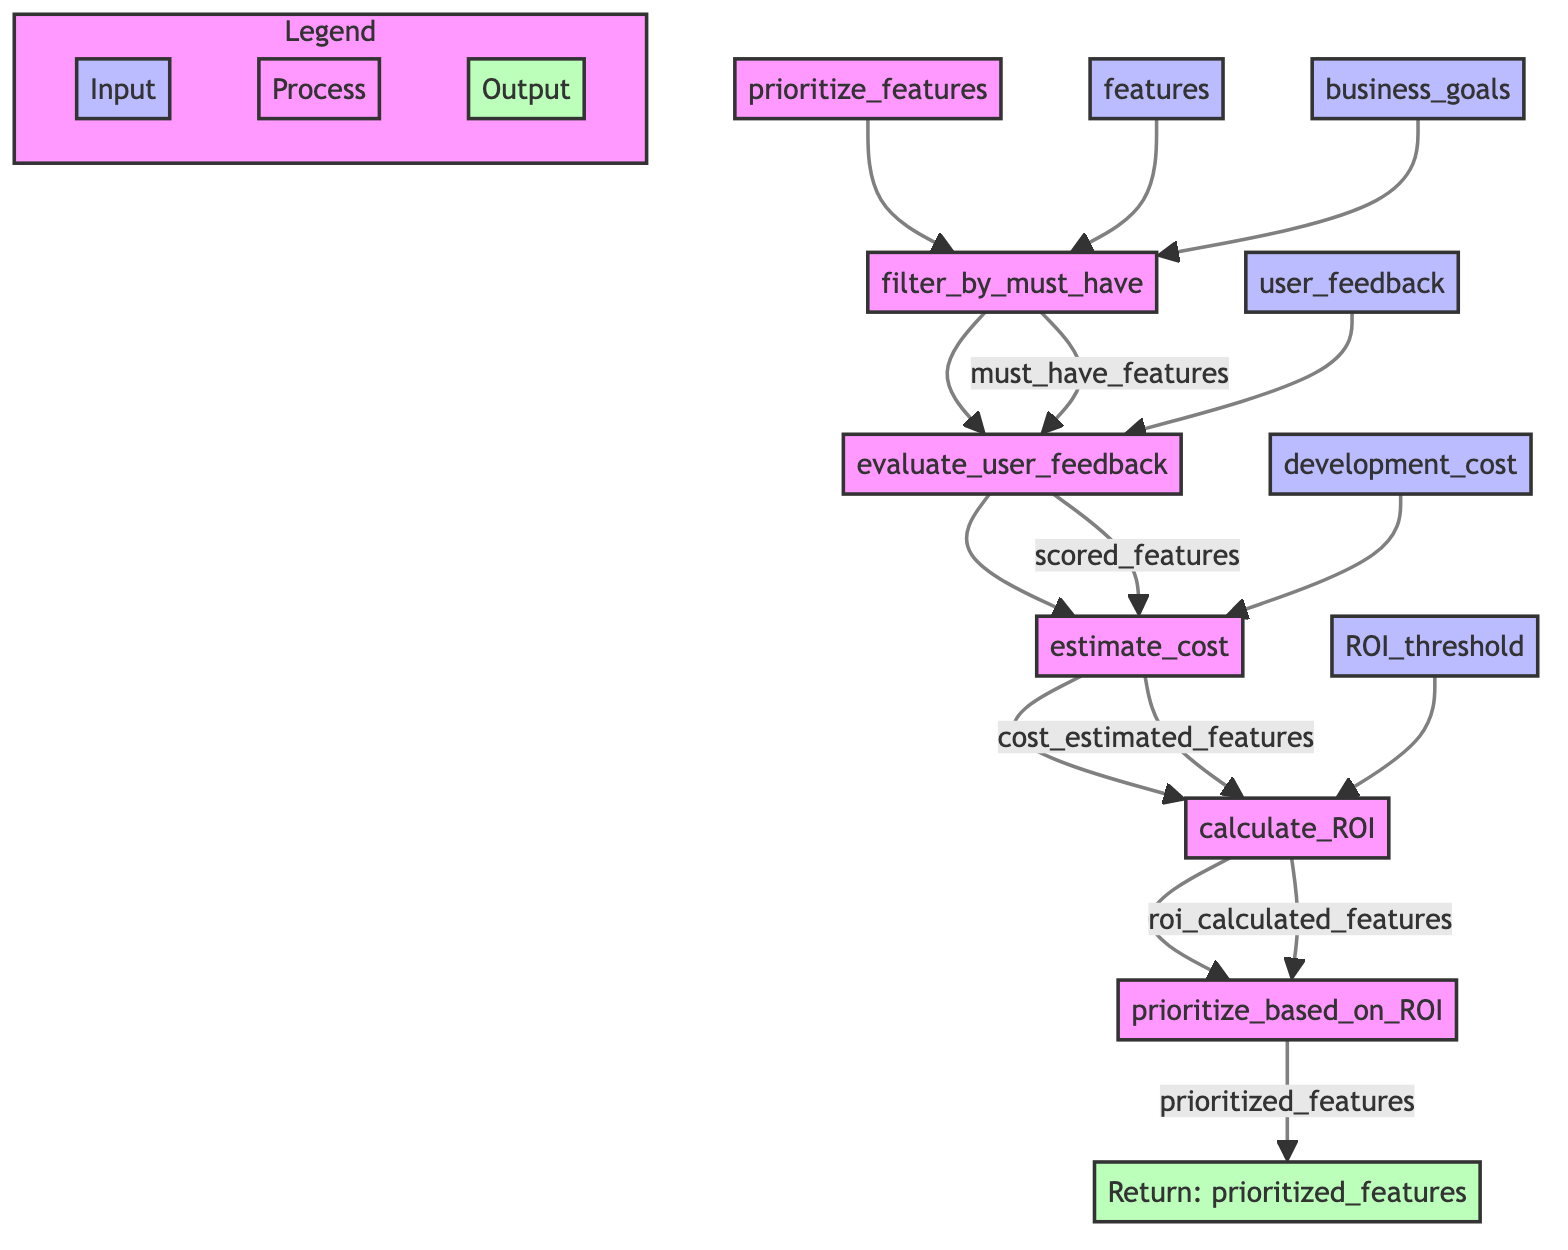What is the first step in the feature prioritization process? The first step in the diagram is "filter_by_must_have," which filters essential features based on business goals.
Answer: filter_by_must_have How many inputs are there to the "evaluate_user_feedback" step? The "evaluate_user_feedback" step receives one input, which is "must_have_features."
Answer: 1 What outputs does the "calculate_ROI" step produce? The "calculate_ROI" step outputs "roi_calculated_features" as its result.
Answer: roi_calculated_features Which step comes after "estimate_cost"? The step that comes after "estimate_cost" is "calculate_ROI." This indicates the sequential flow of tasks in the prioritization process.
Answer: calculate_ROI What is the final output of the function? The final output of the function is "prioritized_features," which contains the features ranked based on ROI and other criteria.
Answer: prioritized_features How many total steps are there in the feature prioritization process? There are five steps in total: filter_by_must_have, evaluate_user_feedback, estimate_cost, calculate_ROI, and prioritize_based_on_ROI.
Answer: 5 Which input goes directly into the "estimate_cost" step? The input that goes directly into the "estimate_cost" step is "scored_features," which are the results from the previous evaluation step.
Answer: scored_features At which step are features ranked based on their ROI scores? Features are ranked based on their ROI scores in the "prioritize_based_on_ROI" step, which follows the ROI calculation.
Answer: prioritize_based_on_ROI What type of relationship exists between "cost_estimated_features" and "calculate_ROI"? The relationship is that "cost_estimated_features" is the output of the "estimate_cost" step and serves as an input to the "calculate_ROI" step.
Answer: output/input relationship 